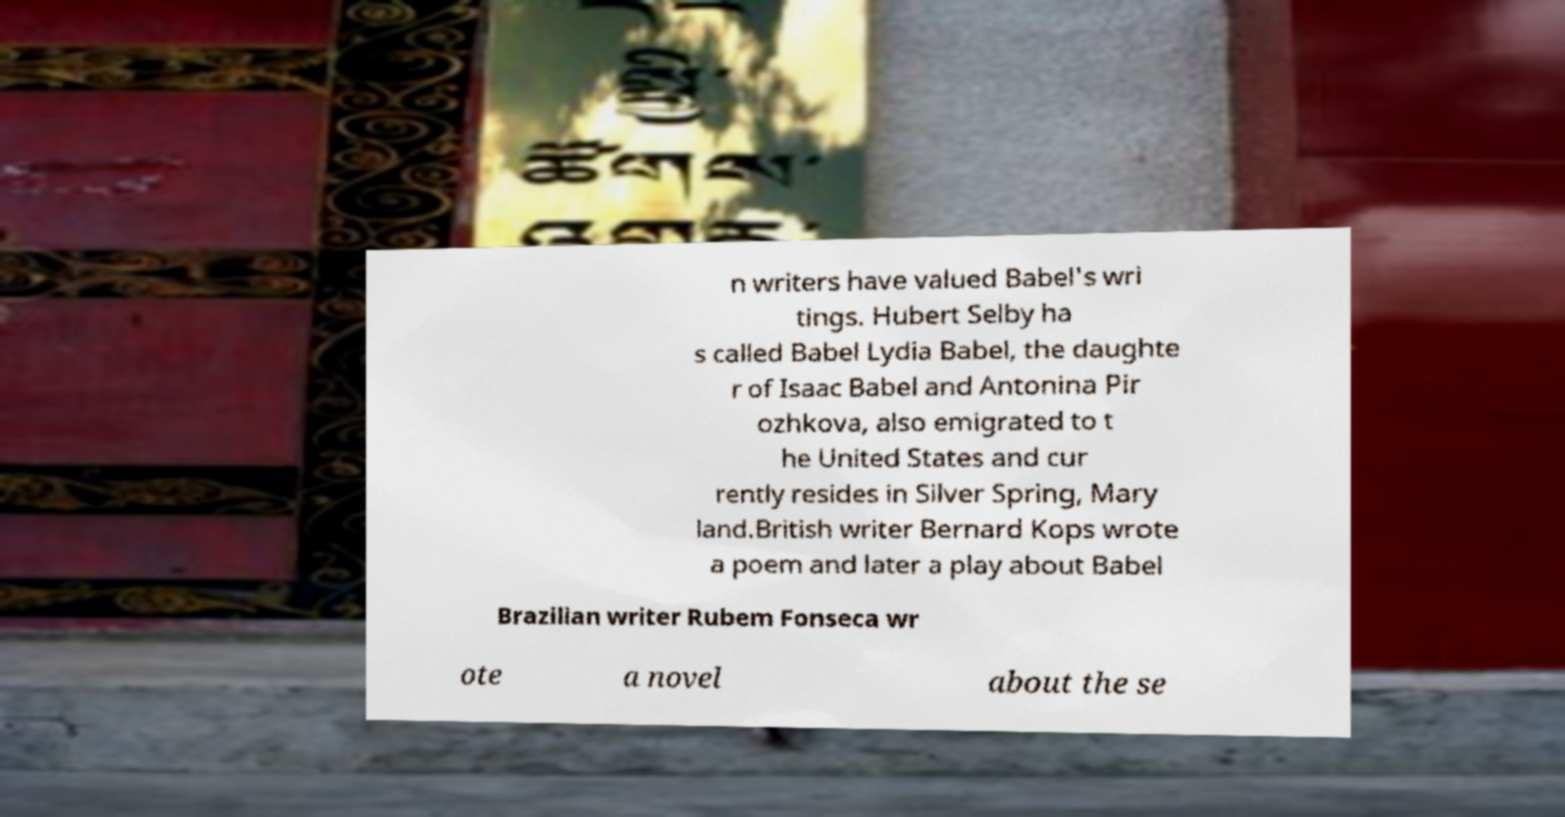Could you assist in decoding the text presented in this image and type it out clearly? n writers have valued Babel's wri tings. Hubert Selby ha s called Babel Lydia Babel, the daughte r of Isaac Babel and Antonina Pir ozhkova, also emigrated to t he United States and cur rently resides in Silver Spring, Mary land.British writer Bernard Kops wrote a poem and later a play about Babel Brazilian writer Rubem Fonseca wr ote a novel about the se 